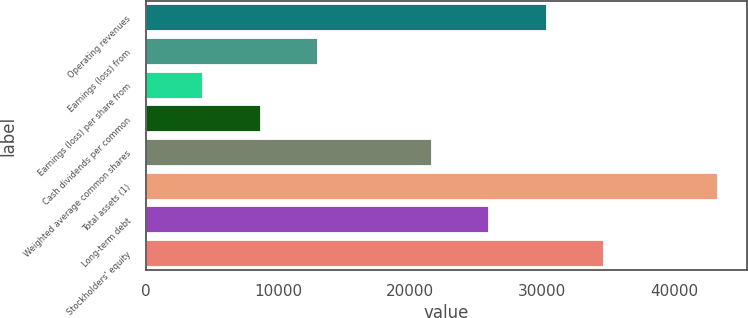<chart> <loc_0><loc_0><loc_500><loc_500><bar_chart><fcel>Operating revenues<fcel>Earnings (loss) from<fcel>Earnings (loss) per share from<fcel>Cash dividends per common<fcel>Weighted average common shares<fcel>Total assets (1)<fcel>Long-term debt<fcel>Stockholders' equity<nl><fcel>30328.3<fcel>12998.1<fcel>4333.02<fcel>8665.57<fcel>21663.2<fcel>43326<fcel>25995.8<fcel>34660.9<nl></chart> 